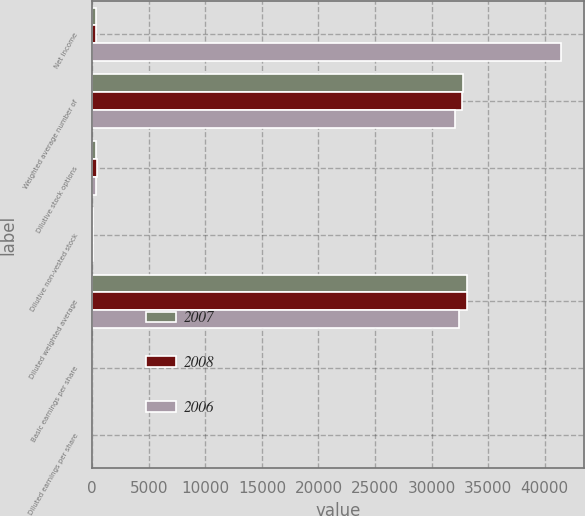<chart> <loc_0><loc_0><loc_500><loc_500><stacked_bar_chart><ecel><fcel>Net income<fcel>Weighted average number of<fcel>Dilutive stock options<fcel>Dilutive non-vested stock<fcel>Diluted weighted average<fcel>Basic earnings per share<fcel>Diluted earnings per share<nl><fcel>2007<fcel>319<fcel>32766<fcel>341<fcel>39<fcel>33146<fcel>2.39<fcel>2.36<nl><fcel>2008<fcel>319<fcel>32672<fcel>397<fcel>77<fcel>33146<fcel>2.16<fcel>2.13<nl><fcel>2006<fcel>41423<fcel>32051<fcel>319<fcel>95<fcel>32465<fcel>1.29<fcel>1.28<nl></chart> 